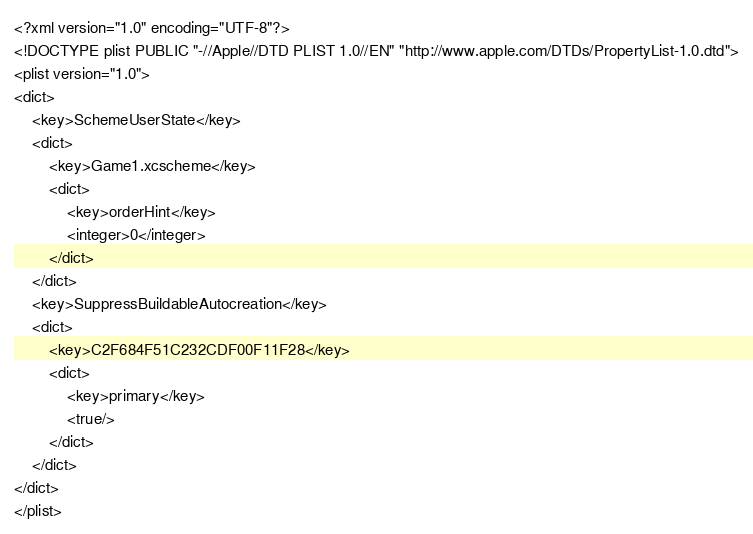Convert code to text. <code><loc_0><loc_0><loc_500><loc_500><_XML_><?xml version="1.0" encoding="UTF-8"?>
<!DOCTYPE plist PUBLIC "-//Apple//DTD PLIST 1.0//EN" "http://www.apple.com/DTDs/PropertyList-1.0.dtd">
<plist version="1.0">
<dict>
	<key>SchemeUserState</key>
	<dict>
		<key>Game1.xcscheme</key>
		<dict>
			<key>orderHint</key>
			<integer>0</integer>
		</dict>
	</dict>
	<key>SuppressBuildableAutocreation</key>
	<dict>
		<key>C2F684F51C232CDF00F11F28</key>
		<dict>
			<key>primary</key>
			<true/>
		</dict>
	</dict>
</dict>
</plist>
</code> 